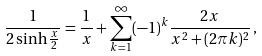Convert formula to latex. <formula><loc_0><loc_0><loc_500><loc_500>\frac { 1 } { 2 \sinh \frac { x } { 2 } } = \frac { 1 } { x } + \sum _ { k = 1 } ^ { \infty } ( - 1 ) ^ { k } \frac { 2 x } { x ^ { 2 } + ( 2 \pi k ) ^ { 2 } } \, ,</formula> 